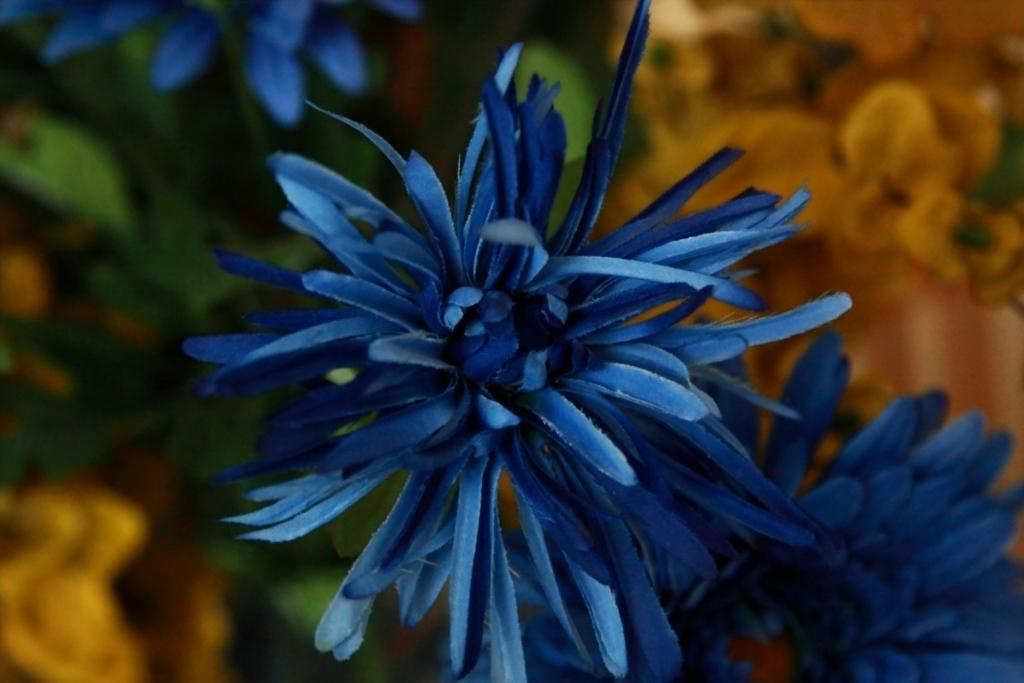Where was the image taken? The image was taken outdoors. What can be observed in the background of the image? The background of the image is blurred. What is the main subject of the image? There are flowers and green leaves in the middle of the image. Can you see a brass instrument being played in the image? There is no brass instrument or any indication of musical activity in the image. 